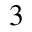Convert formula to latex. <formula><loc_0><loc_0><loc_500><loc_500>^ { 3 }</formula> 